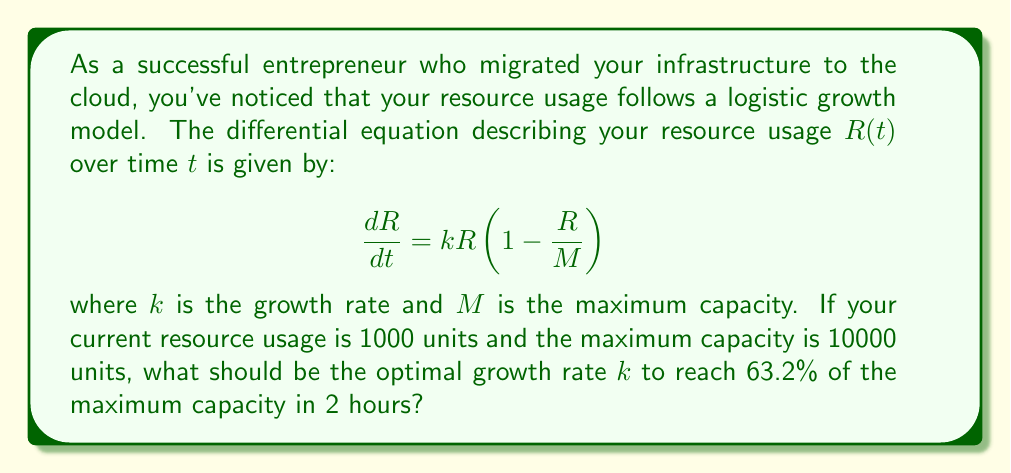Show me your answer to this math problem. To solve this problem, we'll follow these steps:

1) The logistic growth model has the solution:

   $$R(t) = \frac{M}{1 + (\frac{M}{R_0} - 1)e^{-kt}}$$

   where $R_0$ is the initial resource usage.

2) We're given:
   - $R_0 = 1000$ units
   - $M = 10000$ units
   - We want $R(2) = 0.632M = 6320$ units

3) Substituting these values into the solution:

   $$6320 = \frac{10000}{1 + (\frac{10000}{1000} - 1)e^{-2k}}$$

4) Simplify:

   $$0.632 = \frac{1}{1 + 9e^{-2k}}$$

5) Solve for $k$:

   $$1.582278481 = 1 + 9e^{-2k}$$
   $$0.582278481 = 9e^{-2k}$$
   $$0.064697609 = e^{-2k}$$
   $$\ln(0.064697609) = -2k$$
   $$-2.738047982 = -2k$$

6) Therefore:

   $$k = 1.369023991$$

This value of $k$ will ensure that the resource usage reaches 63.2% of the maximum capacity in 2 hours.
Answer: $k \approx 1.369$ per hour 